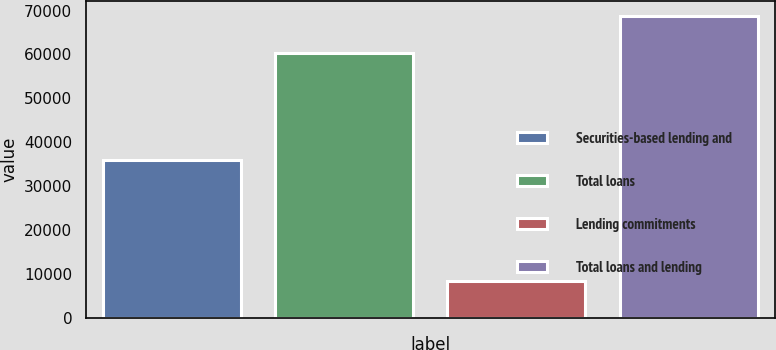<chart> <loc_0><loc_0><loc_500><loc_500><bar_chart><fcel>Securities-based lending and<fcel>Total loans<fcel>Lending commitments<fcel>Total loans and lending<nl><fcel>36013<fcel>60427<fcel>8299<fcel>68726<nl></chart> 